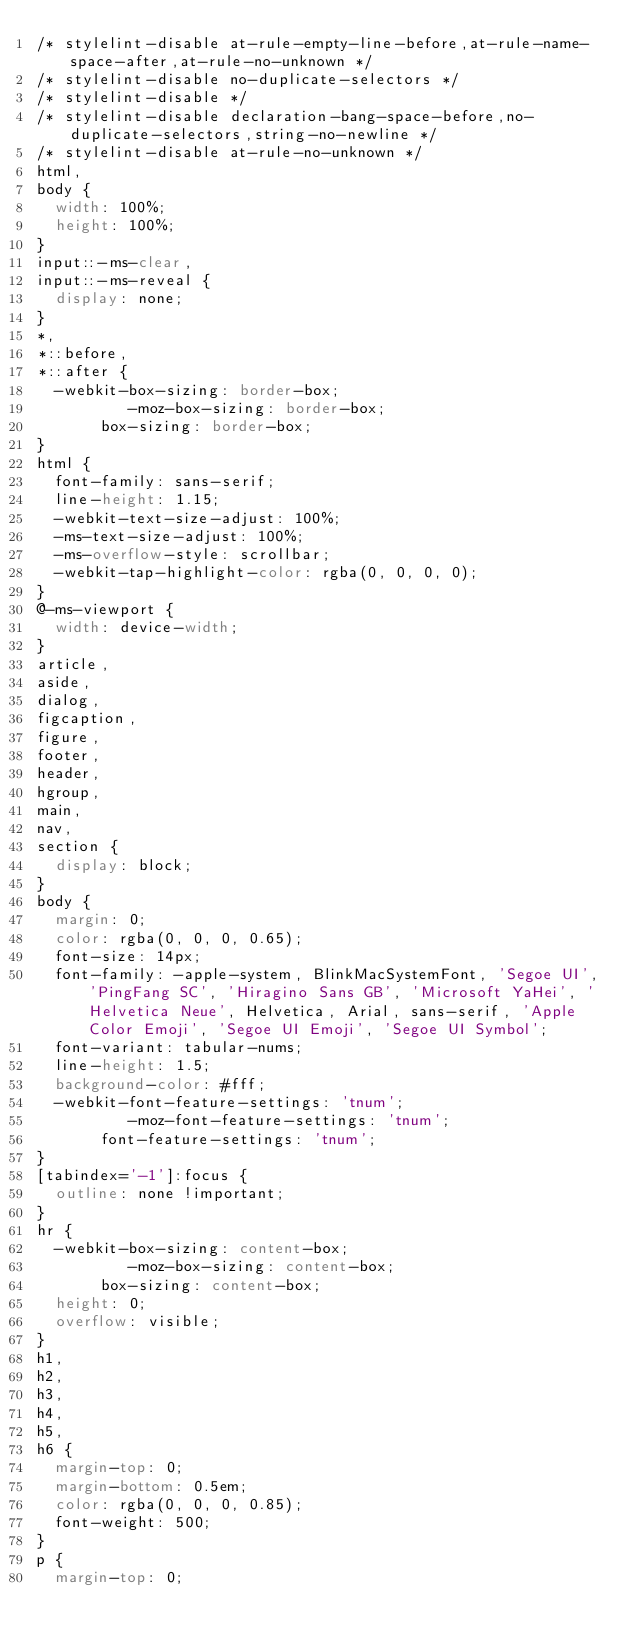Convert code to text. <code><loc_0><loc_0><loc_500><loc_500><_CSS_>/* stylelint-disable at-rule-empty-line-before,at-rule-name-space-after,at-rule-no-unknown */
/* stylelint-disable no-duplicate-selectors */
/* stylelint-disable */
/* stylelint-disable declaration-bang-space-before,no-duplicate-selectors,string-no-newline */
/* stylelint-disable at-rule-no-unknown */
html,
body {
  width: 100%;
  height: 100%;
}
input::-ms-clear,
input::-ms-reveal {
  display: none;
}
*,
*::before,
*::after {
  -webkit-box-sizing: border-box;
          -moz-box-sizing: border-box;
       box-sizing: border-box;
}
html {
  font-family: sans-serif;
  line-height: 1.15;
  -webkit-text-size-adjust: 100%;
  -ms-text-size-adjust: 100%;
  -ms-overflow-style: scrollbar;
  -webkit-tap-highlight-color: rgba(0, 0, 0, 0);
}
@-ms-viewport {
  width: device-width;
}
article,
aside,
dialog,
figcaption,
figure,
footer,
header,
hgroup,
main,
nav,
section {
  display: block;
}
body {
  margin: 0;
  color: rgba(0, 0, 0, 0.65);
  font-size: 14px;
  font-family: -apple-system, BlinkMacSystemFont, 'Segoe UI', 'PingFang SC', 'Hiragino Sans GB', 'Microsoft YaHei', 'Helvetica Neue', Helvetica, Arial, sans-serif, 'Apple Color Emoji', 'Segoe UI Emoji', 'Segoe UI Symbol';
  font-variant: tabular-nums;
  line-height: 1.5;
  background-color: #fff;
  -webkit-font-feature-settings: 'tnum';
          -moz-font-feature-settings: 'tnum';
       font-feature-settings: 'tnum';
}
[tabindex='-1']:focus {
  outline: none !important;
}
hr {
  -webkit-box-sizing: content-box;
          -moz-box-sizing: content-box;
       box-sizing: content-box;
  height: 0;
  overflow: visible;
}
h1,
h2,
h3,
h4,
h5,
h6 {
  margin-top: 0;
  margin-bottom: 0.5em;
  color: rgba(0, 0, 0, 0.85);
  font-weight: 500;
}
p {
  margin-top: 0;</code> 